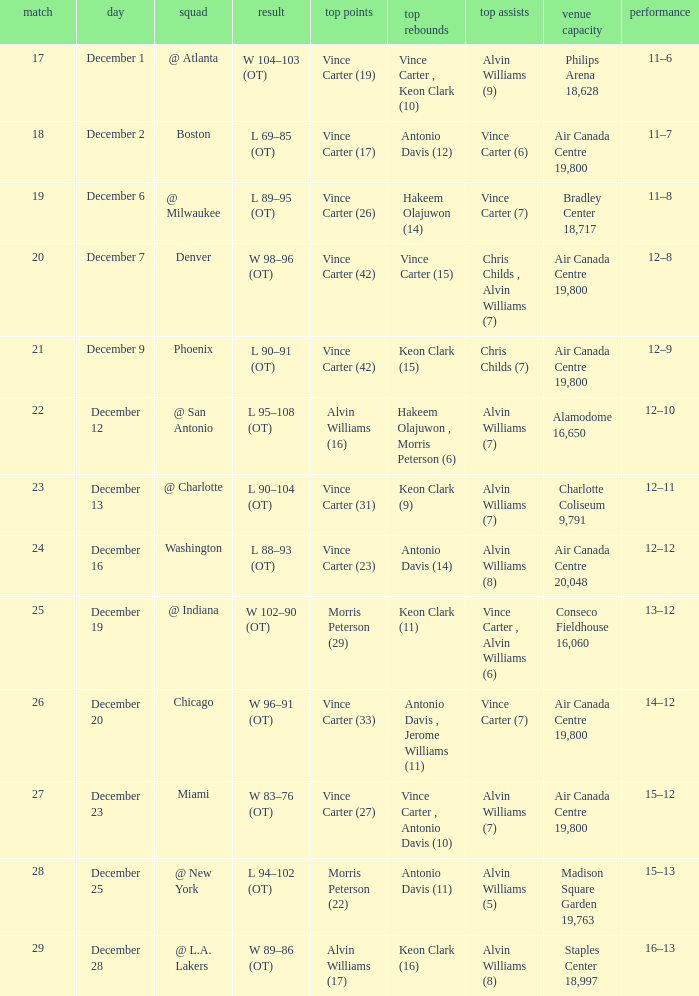What game happened on December 19? 25.0. 